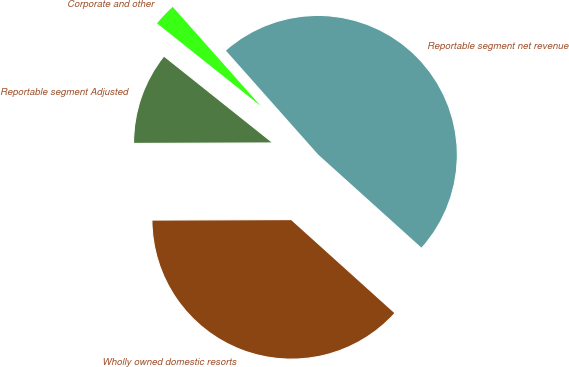Convert chart to OTSL. <chart><loc_0><loc_0><loc_500><loc_500><pie_chart><fcel>Wholly owned domestic resorts<fcel>Reportable segment net revenue<fcel>Corporate and other<fcel>Reportable segment Adjusted<nl><fcel>38.27%<fcel>48.23%<fcel>2.74%<fcel>10.76%<nl></chart> 